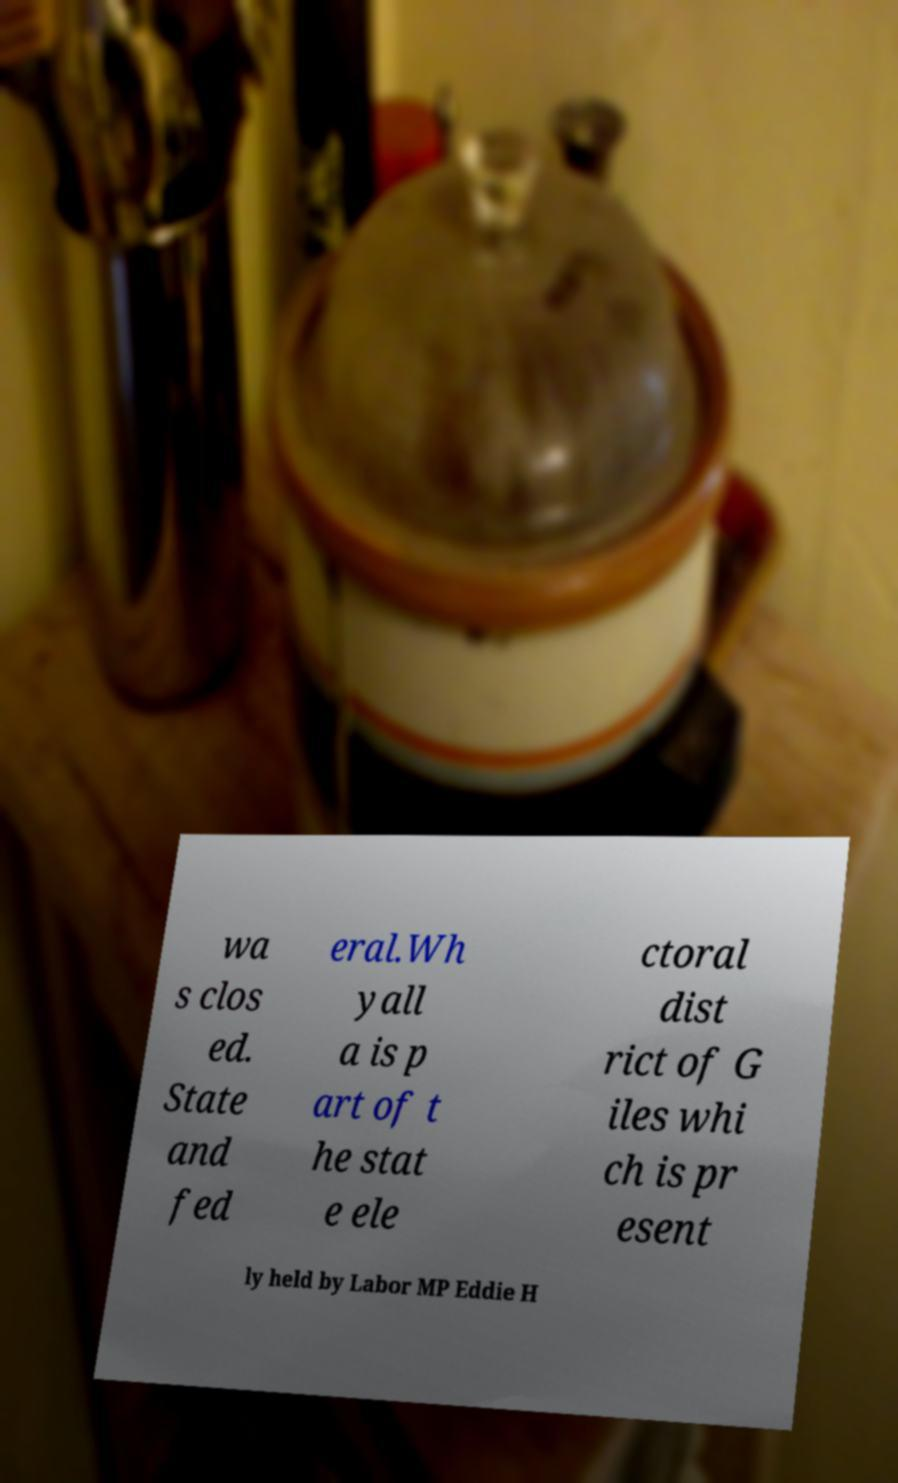Could you assist in decoding the text presented in this image and type it out clearly? wa s clos ed. State and fed eral.Wh yall a is p art of t he stat e ele ctoral dist rict of G iles whi ch is pr esent ly held by Labor MP Eddie H 